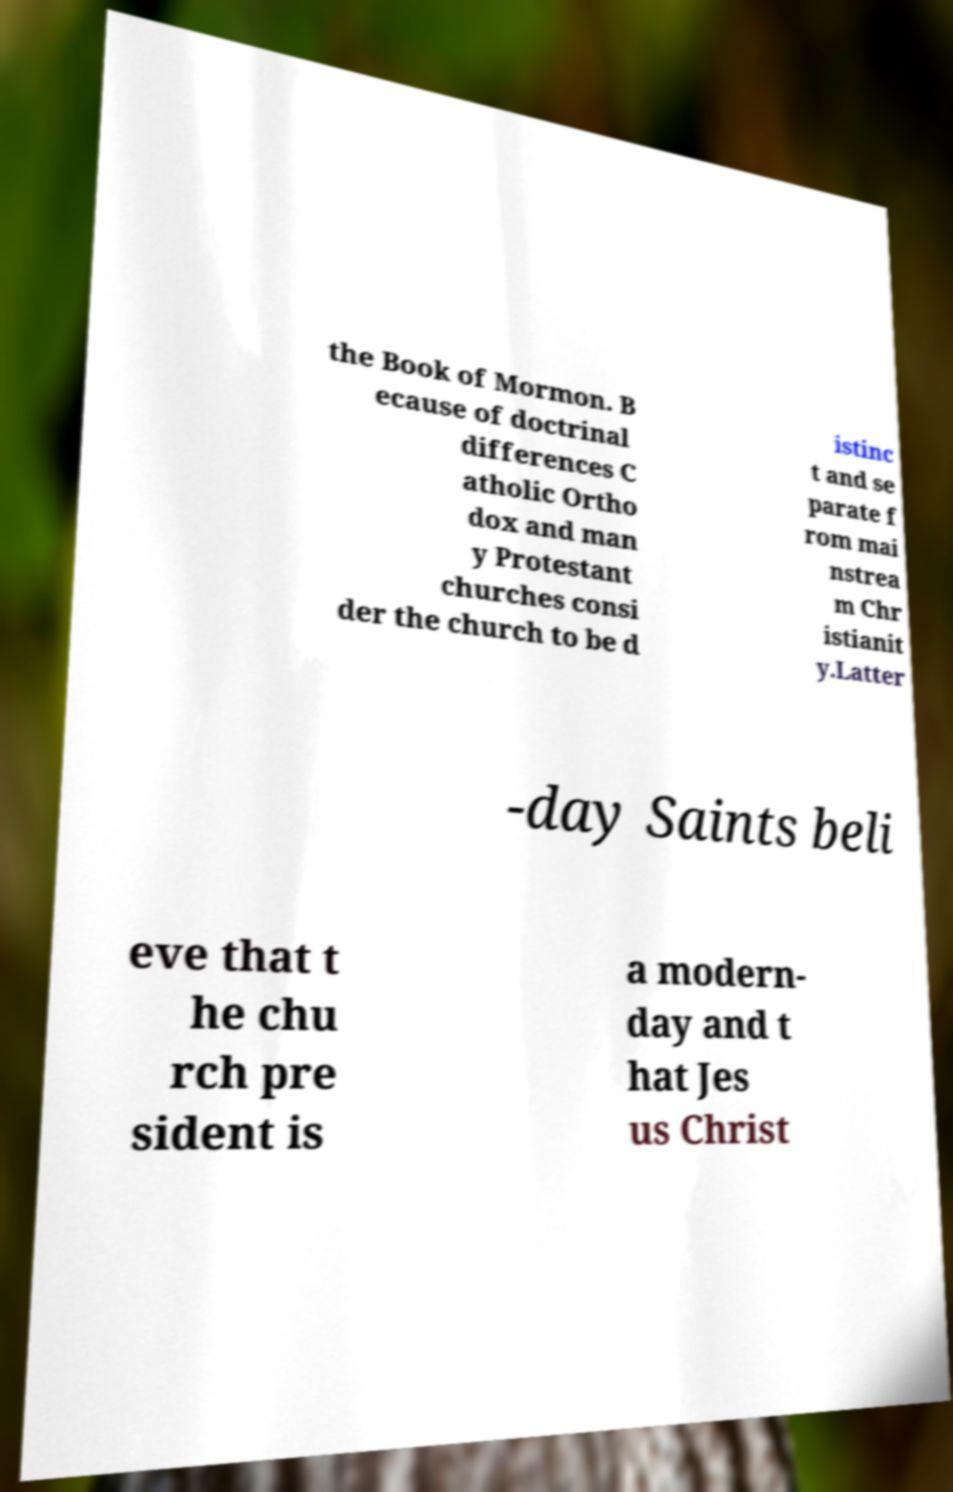Could you assist in decoding the text presented in this image and type it out clearly? the Book of Mormon. B ecause of doctrinal differences C atholic Ortho dox and man y Protestant churches consi der the church to be d istinc t and se parate f rom mai nstrea m Chr istianit y.Latter -day Saints beli eve that t he chu rch pre sident is a modern- day and t hat Jes us Christ 